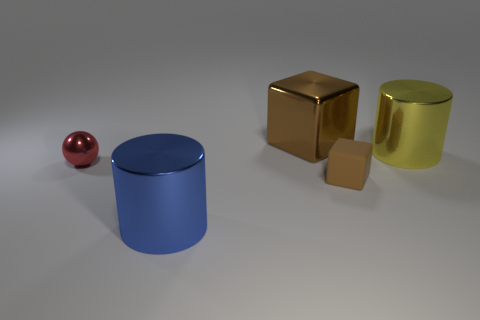Add 3 metallic spheres. How many objects exist? 8 Subtract all cylinders. How many objects are left? 3 Add 5 small balls. How many small balls are left? 6 Add 3 red spheres. How many red spheres exist? 4 Subtract 0 purple blocks. How many objects are left? 5 Subtract all balls. Subtract all tiny spheres. How many objects are left? 3 